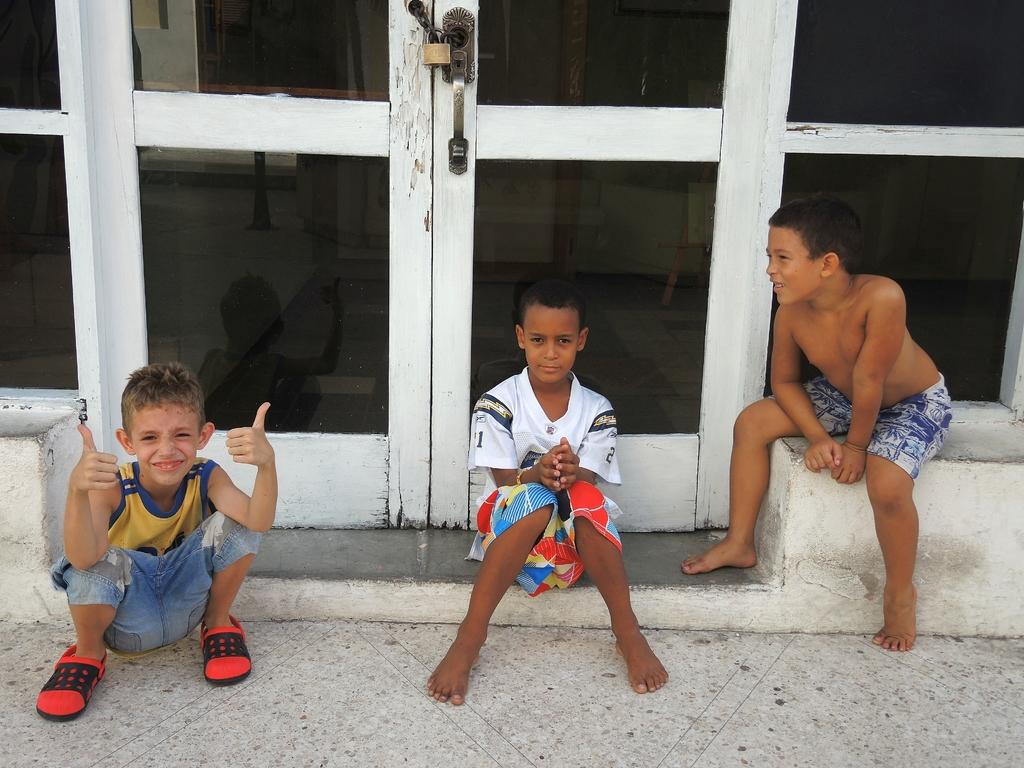What can be seen in the image that allows access to different areas? There are doors in the image. How many people are sitting in the front of the image? There are three people sitting in the front of the image. Can you see a frog jumping in the image? There is no frog present in the image. What type of cloud can be seen in the image? There is no cloud visible in the image. 